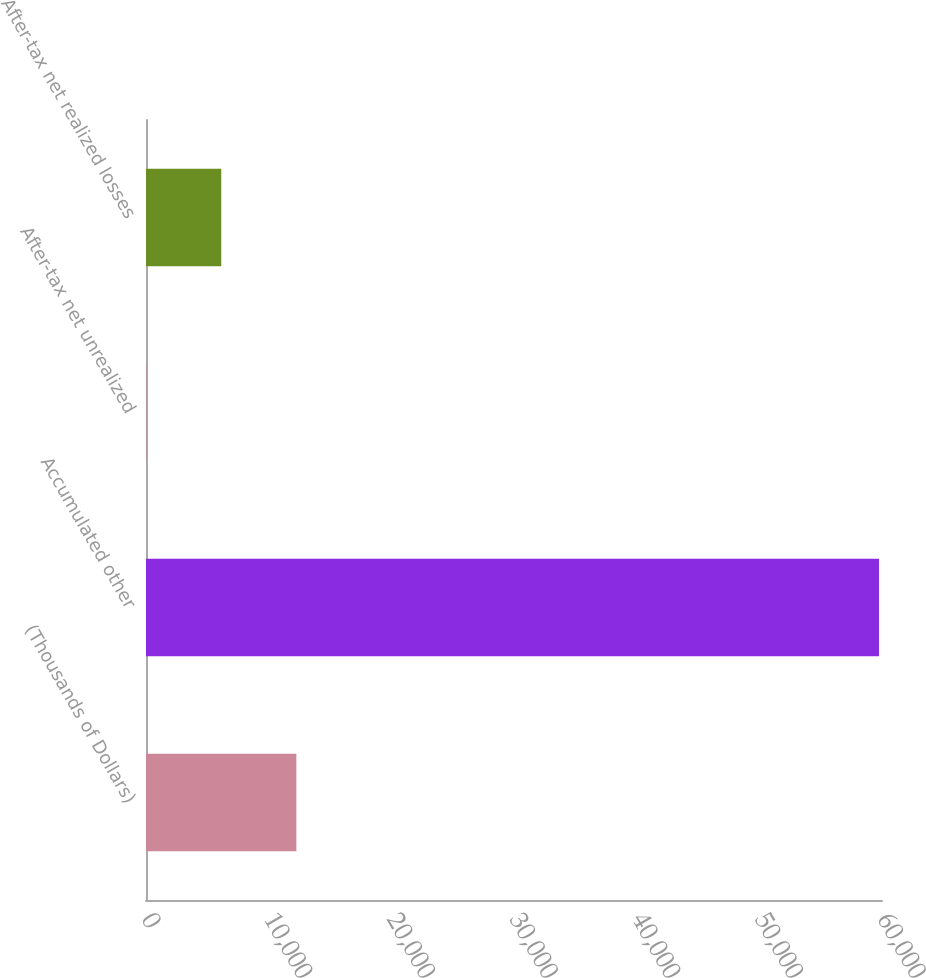<chart> <loc_0><loc_0><loc_500><loc_500><bar_chart><fcel>(Thousands of Dollars)<fcel>Accumulated other<fcel>After-tax net unrealized<fcel>After-tax net realized losses<nl><fcel>12257.8<fcel>59753<fcel>12<fcel>6134.9<nl></chart> 